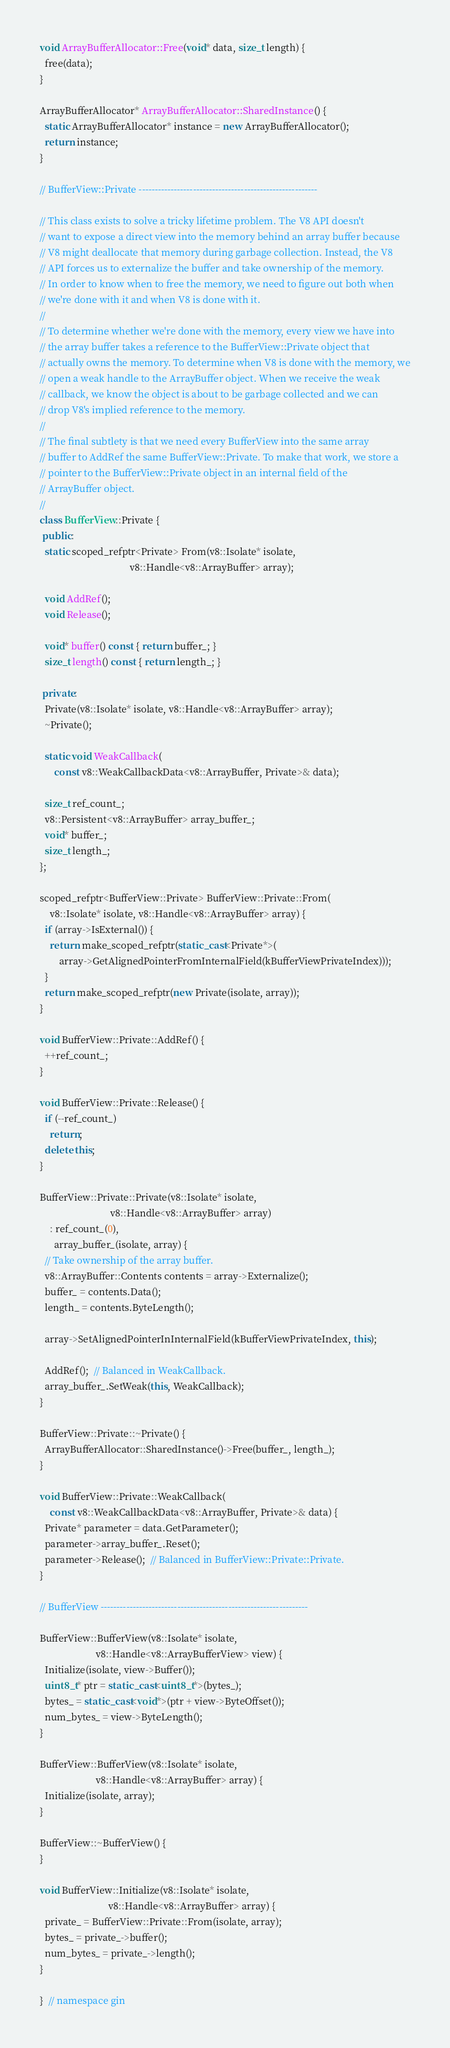<code> <loc_0><loc_0><loc_500><loc_500><_C++_>
void ArrayBufferAllocator::Free(void* data, size_t length) {
  free(data);
}

ArrayBufferAllocator* ArrayBufferAllocator::SharedInstance() {
  static ArrayBufferAllocator* instance = new ArrayBufferAllocator();
  return instance;
}

// BufferView::Private --------------------------------------------------------

// This class exists to solve a tricky lifetime problem. The V8 API doesn't
// want to expose a direct view into the memory behind an array buffer because
// V8 might deallocate that memory during garbage collection. Instead, the V8
// API forces us to externalize the buffer and take ownership of the memory.
// In order to know when to free the memory, we need to figure out both when
// we're done with it and when V8 is done with it.
//
// To determine whether we're done with the memory, every view we have into
// the array buffer takes a reference to the BufferView::Private object that
// actually owns the memory. To determine when V8 is done with the memory, we
// open a weak handle to the ArrayBuffer object. When we receive the weak
// callback, we know the object is about to be garbage collected and we can
// drop V8's implied reference to the memory.
//
// The final subtlety is that we need every BufferView into the same array
// buffer to AddRef the same BufferView::Private. To make that work, we store a
// pointer to the BufferView::Private object in an internal field of the
// ArrayBuffer object.
//
class BufferView::Private {
 public:
  static scoped_refptr<Private> From(v8::Isolate* isolate,
                                     v8::Handle<v8::ArrayBuffer> array);

  void AddRef();
  void Release();

  void* buffer() const { return buffer_; }
  size_t length() const { return length_; }

 private:
  Private(v8::Isolate* isolate, v8::Handle<v8::ArrayBuffer> array);
  ~Private();

  static void WeakCallback(
      const v8::WeakCallbackData<v8::ArrayBuffer, Private>& data);

  size_t ref_count_;
  v8::Persistent<v8::ArrayBuffer> array_buffer_;
  void* buffer_;
  size_t length_;
};

scoped_refptr<BufferView::Private> BufferView::Private::From(
    v8::Isolate* isolate, v8::Handle<v8::ArrayBuffer> array) {
  if (array->IsExternal()) {
    return make_scoped_refptr(static_cast<Private*>(
        array->GetAlignedPointerFromInternalField(kBufferViewPrivateIndex)));
  }
  return make_scoped_refptr(new Private(isolate, array));
}

void BufferView::Private::AddRef() {
  ++ref_count_;
}

void BufferView::Private::Release() {
  if (--ref_count_)
    return;
  delete this;
}

BufferView::Private::Private(v8::Isolate* isolate,
                             v8::Handle<v8::ArrayBuffer> array)
    : ref_count_(0),
      array_buffer_(isolate, array) {
  // Take ownership of the array buffer.
  v8::ArrayBuffer::Contents contents = array->Externalize();
  buffer_ = contents.Data();
  length_ = contents.ByteLength();

  array->SetAlignedPointerInInternalField(kBufferViewPrivateIndex, this);

  AddRef();  // Balanced in WeakCallback.
  array_buffer_.SetWeak(this, WeakCallback);
}

BufferView::Private::~Private() {
  ArrayBufferAllocator::SharedInstance()->Free(buffer_, length_);
}

void BufferView::Private::WeakCallback(
    const v8::WeakCallbackData<v8::ArrayBuffer, Private>& data) {
  Private* parameter = data.GetParameter();
  parameter->array_buffer_.Reset();
  parameter->Release();  // Balanced in BufferView::Private::Private.
}

// BufferView -----------------------------------------------------------------

BufferView::BufferView(v8::Isolate* isolate,
                       v8::Handle<v8::ArrayBufferView> view) {
  Initialize(isolate, view->Buffer());
  uint8_t* ptr = static_cast<uint8_t*>(bytes_);
  bytes_ = static_cast<void*>(ptr + view->ByteOffset());
  num_bytes_ = view->ByteLength();
}

BufferView::BufferView(v8::Isolate* isolate,
                       v8::Handle<v8::ArrayBuffer> array) {
  Initialize(isolate, array);
}

BufferView::~BufferView() {
}

void BufferView::Initialize(v8::Isolate* isolate,
                            v8::Handle<v8::ArrayBuffer> array) {
  private_ = BufferView::Private::From(isolate, array);
  bytes_ = private_->buffer();
  num_bytes_ = private_->length();
}

}  // namespace gin
</code> 